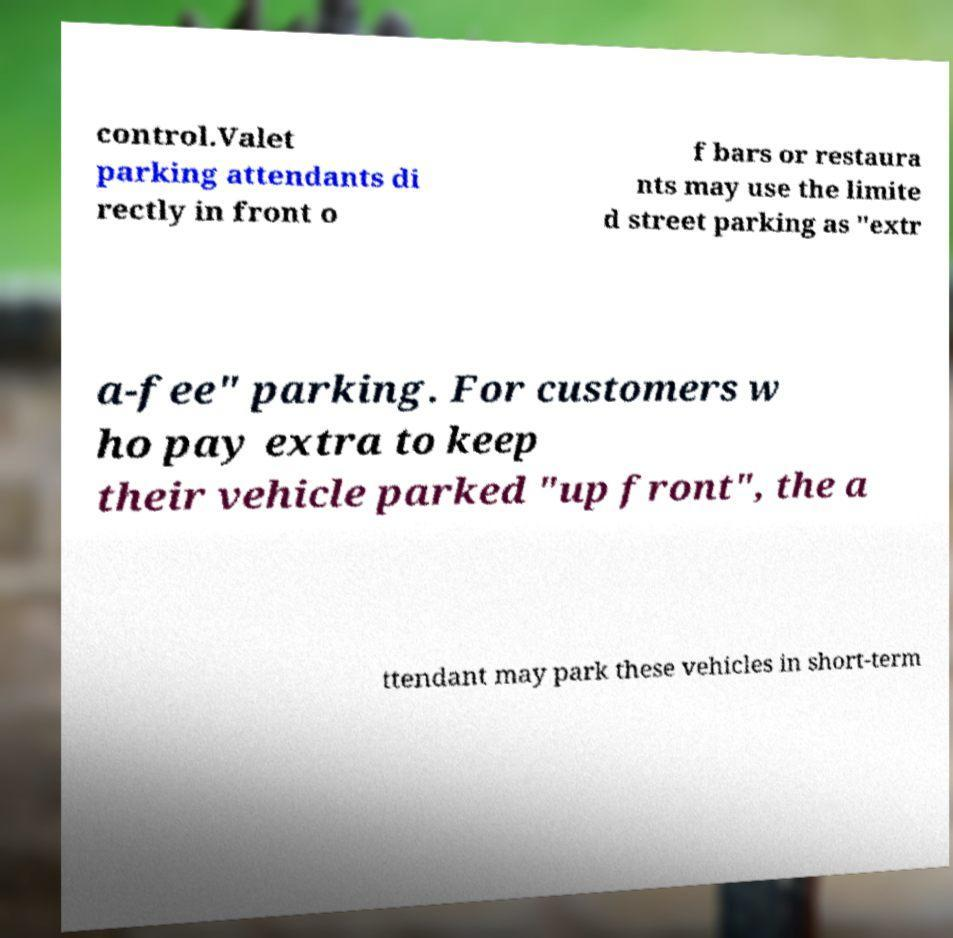There's text embedded in this image that I need extracted. Can you transcribe it verbatim? control.Valet parking attendants di rectly in front o f bars or restaura nts may use the limite d street parking as "extr a-fee" parking. For customers w ho pay extra to keep their vehicle parked "up front", the a ttendant may park these vehicles in short-term 